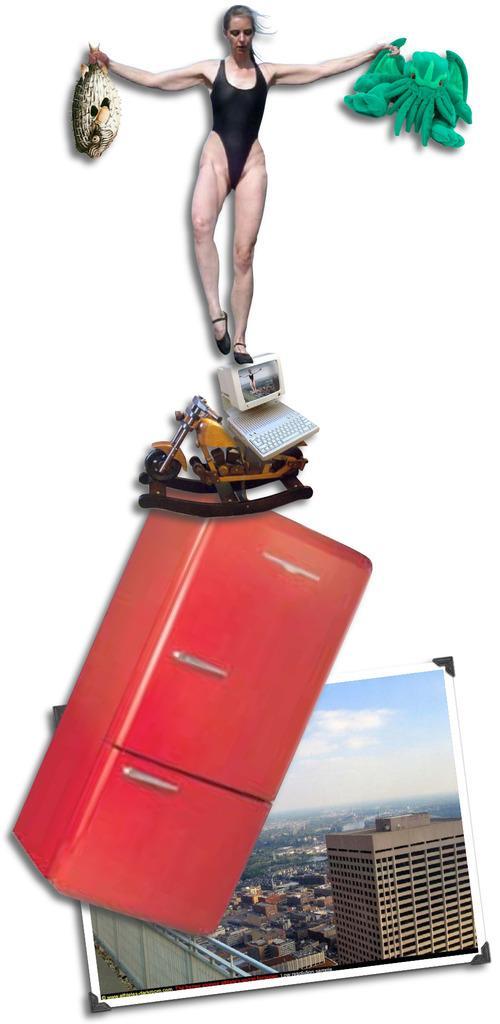Please provide a concise description of this image. This is an edited picture, in this image we can see a woman standing and holding the objects, also we can see a monitor, keyboard, photo frame and some other objects. 